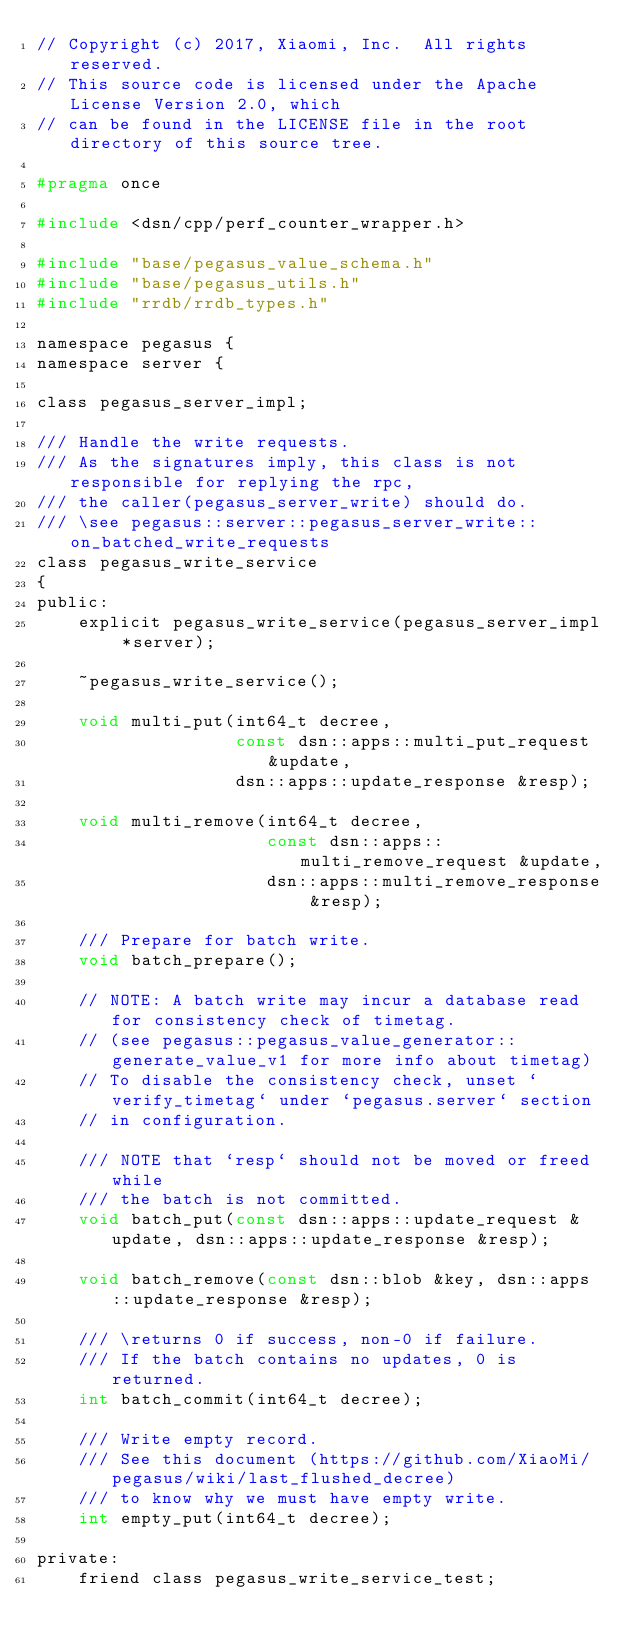<code> <loc_0><loc_0><loc_500><loc_500><_C_>// Copyright (c) 2017, Xiaomi, Inc.  All rights reserved.
// This source code is licensed under the Apache License Version 2.0, which
// can be found in the LICENSE file in the root directory of this source tree.

#pragma once

#include <dsn/cpp/perf_counter_wrapper.h>

#include "base/pegasus_value_schema.h"
#include "base/pegasus_utils.h"
#include "rrdb/rrdb_types.h"

namespace pegasus {
namespace server {

class pegasus_server_impl;

/// Handle the write requests.
/// As the signatures imply, this class is not responsible for replying the rpc,
/// the caller(pegasus_server_write) should do.
/// \see pegasus::server::pegasus_server_write::on_batched_write_requests
class pegasus_write_service
{
public:
    explicit pegasus_write_service(pegasus_server_impl *server);

    ~pegasus_write_service();

    void multi_put(int64_t decree,
                   const dsn::apps::multi_put_request &update,
                   dsn::apps::update_response &resp);

    void multi_remove(int64_t decree,
                      const dsn::apps::multi_remove_request &update,
                      dsn::apps::multi_remove_response &resp);

    /// Prepare for batch write.
    void batch_prepare();

    // NOTE: A batch write may incur a database read for consistency check of timetag.
    // (see pegasus::pegasus_value_generator::generate_value_v1 for more info about timetag)
    // To disable the consistency check, unset `verify_timetag` under `pegasus.server` section
    // in configuration.

    /// NOTE that `resp` should not be moved or freed while
    /// the batch is not committed.
    void batch_put(const dsn::apps::update_request &update, dsn::apps::update_response &resp);

    void batch_remove(const dsn::blob &key, dsn::apps::update_response &resp);

    /// \returns 0 if success, non-0 if failure.
    /// If the batch contains no updates, 0 is returned.
    int batch_commit(int64_t decree);

    /// Write empty record.
    /// See this document (https://github.com/XiaoMi/pegasus/wiki/last_flushed_decree)
    /// to know why we must have empty write.
    int empty_put(int64_t decree);

private:
    friend class pegasus_write_service_test;
</code> 